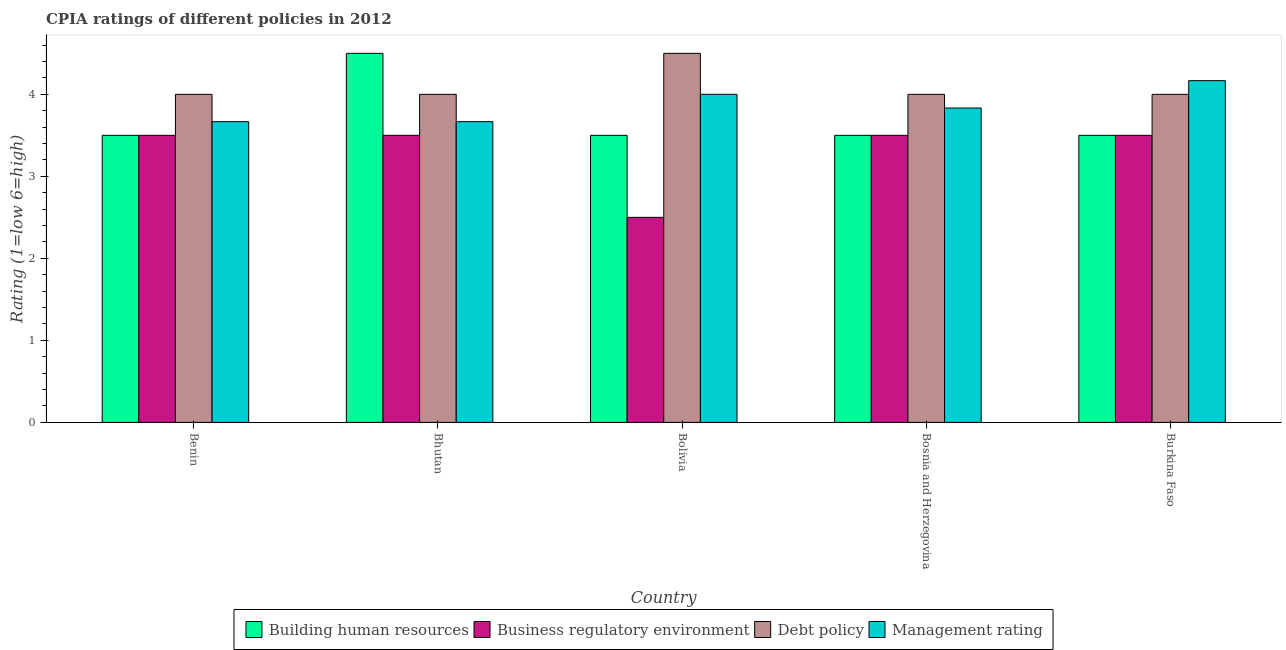How many groups of bars are there?
Offer a terse response. 5. How many bars are there on the 5th tick from the left?
Offer a very short reply. 4. How many bars are there on the 2nd tick from the right?
Your response must be concise. 4. What is the label of the 3rd group of bars from the left?
Make the answer very short. Bolivia. In how many cases, is the number of bars for a given country not equal to the number of legend labels?
Keep it short and to the point. 0. In which country was the cpia rating of building human resources maximum?
Make the answer very short. Bhutan. What is the difference between the cpia rating of debt policy in Burkina Faso and the cpia rating of management in Benin?
Give a very brief answer. 0.33. What is the average cpia rating of business regulatory environment per country?
Your answer should be compact. 3.3. What is the difference between the cpia rating of management and cpia rating of building human resources in Bolivia?
Ensure brevity in your answer.  0.5. In how many countries, is the cpia rating of building human resources greater than 2.4 ?
Offer a terse response. 5. What is the difference between the highest and the second highest cpia rating of management?
Give a very brief answer. 0.17. What is the difference between the highest and the lowest cpia rating of building human resources?
Offer a terse response. 1. In how many countries, is the cpia rating of management greater than the average cpia rating of management taken over all countries?
Offer a terse response. 2. What does the 4th bar from the left in Bhutan represents?
Make the answer very short. Management rating. What does the 2nd bar from the right in Bhutan represents?
Keep it short and to the point. Debt policy. Is it the case that in every country, the sum of the cpia rating of building human resources and cpia rating of business regulatory environment is greater than the cpia rating of debt policy?
Provide a succinct answer. Yes. How many bars are there?
Keep it short and to the point. 20. Are all the bars in the graph horizontal?
Your answer should be very brief. No. How many countries are there in the graph?
Provide a succinct answer. 5. What is the difference between two consecutive major ticks on the Y-axis?
Keep it short and to the point. 1. Does the graph contain grids?
Offer a terse response. No. How are the legend labels stacked?
Make the answer very short. Horizontal. What is the title of the graph?
Keep it short and to the point. CPIA ratings of different policies in 2012. What is the label or title of the X-axis?
Provide a short and direct response. Country. What is the Rating (1=low 6=high) of Business regulatory environment in Benin?
Your response must be concise. 3.5. What is the Rating (1=low 6=high) in Debt policy in Benin?
Offer a terse response. 4. What is the Rating (1=low 6=high) of Management rating in Benin?
Offer a very short reply. 3.67. What is the Rating (1=low 6=high) of Debt policy in Bhutan?
Give a very brief answer. 4. What is the Rating (1=low 6=high) of Management rating in Bhutan?
Keep it short and to the point. 3.67. What is the Rating (1=low 6=high) of Debt policy in Bolivia?
Offer a terse response. 4.5. What is the Rating (1=low 6=high) in Management rating in Bolivia?
Ensure brevity in your answer.  4. What is the Rating (1=low 6=high) in Building human resources in Bosnia and Herzegovina?
Your response must be concise. 3.5. What is the Rating (1=low 6=high) of Management rating in Bosnia and Herzegovina?
Offer a terse response. 3.83. What is the Rating (1=low 6=high) in Building human resources in Burkina Faso?
Your answer should be very brief. 3.5. What is the Rating (1=low 6=high) of Management rating in Burkina Faso?
Make the answer very short. 4.17. Across all countries, what is the maximum Rating (1=low 6=high) of Building human resources?
Keep it short and to the point. 4.5. Across all countries, what is the maximum Rating (1=low 6=high) of Business regulatory environment?
Provide a succinct answer. 3.5. Across all countries, what is the maximum Rating (1=low 6=high) of Debt policy?
Offer a very short reply. 4.5. Across all countries, what is the maximum Rating (1=low 6=high) in Management rating?
Your answer should be very brief. 4.17. Across all countries, what is the minimum Rating (1=low 6=high) in Building human resources?
Your answer should be very brief. 3.5. Across all countries, what is the minimum Rating (1=low 6=high) in Management rating?
Give a very brief answer. 3.67. What is the total Rating (1=low 6=high) in Building human resources in the graph?
Your answer should be compact. 18.5. What is the total Rating (1=low 6=high) of Debt policy in the graph?
Make the answer very short. 20.5. What is the total Rating (1=low 6=high) of Management rating in the graph?
Your response must be concise. 19.33. What is the difference between the Rating (1=low 6=high) in Building human resources in Benin and that in Bhutan?
Offer a very short reply. -1. What is the difference between the Rating (1=low 6=high) of Business regulatory environment in Benin and that in Bhutan?
Offer a terse response. 0. What is the difference between the Rating (1=low 6=high) in Debt policy in Benin and that in Bhutan?
Offer a terse response. 0. What is the difference between the Rating (1=low 6=high) in Management rating in Benin and that in Bhutan?
Your answer should be compact. 0. What is the difference between the Rating (1=low 6=high) of Building human resources in Benin and that in Bolivia?
Ensure brevity in your answer.  0. What is the difference between the Rating (1=low 6=high) in Business regulatory environment in Benin and that in Bolivia?
Your answer should be compact. 1. What is the difference between the Rating (1=low 6=high) in Debt policy in Benin and that in Bolivia?
Ensure brevity in your answer.  -0.5. What is the difference between the Rating (1=low 6=high) in Management rating in Benin and that in Bolivia?
Your answer should be compact. -0.33. What is the difference between the Rating (1=low 6=high) in Building human resources in Benin and that in Bosnia and Herzegovina?
Your response must be concise. 0. What is the difference between the Rating (1=low 6=high) in Business regulatory environment in Benin and that in Bosnia and Herzegovina?
Give a very brief answer. 0. What is the difference between the Rating (1=low 6=high) of Debt policy in Benin and that in Bosnia and Herzegovina?
Offer a terse response. 0. What is the difference between the Rating (1=low 6=high) in Business regulatory environment in Benin and that in Burkina Faso?
Keep it short and to the point. 0. What is the difference between the Rating (1=low 6=high) in Debt policy in Benin and that in Burkina Faso?
Your answer should be very brief. 0. What is the difference between the Rating (1=low 6=high) of Management rating in Benin and that in Burkina Faso?
Your answer should be very brief. -0.5. What is the difference between the Rating (1=low 6=high) in Debt policy in Bhutan and that in Bolivia?
Your answer should be compact. -0.5. What is the difference between the Rating (1=low 6=high) in Building human resources in Bhutan and that in Bosnia and Herzegovina?
Give a very brief answer. 1. What is the difference between the Rating (1=low 6=high) in Business regulatory environment in Bhutan and that in Bosnia and Herzegovina?
Your answer should be very brief. 0. What is the difference between the Rating (1=low 6=high) of Building human resources in Bhutan and that in Burkina Faso?
Provide a succinct answer. 1. What is the difference between the Rating (1=low 6=high) of Business regulatory environment in Bhutan and that in Burkina Faso?
Provide a short and direct response. 0. What is the difference between the Rating (1=low 6=high) in Management rating in Bhutan and that in Burkina Faso?
Your answer should be compact. -0.5. What is the difference between the Rating (1=low 6=high) in Building human resources in Bolivia and that in Bosnia and Herzegovina?
Ensure brevity in your answer.  0. What is the difference between the Rating (1=low 6=high) in Business regulatory environment in Bolivia and that in Bosnia and Herzegovina?
Provide a succinct answer. -1. What is the difference between the Rating (1=low 6=high) of Management rating in Bolivia and that in Bosnia and Herzegovina?
Your answer should be compact. 0.17. What is the difference between the Rating (1=low 6=high) of Business regulatory environment in Bolivia and that in Burkina Faso?
Your answer should be very brief. -1. What is the difference between the Rating (1=low 6=high) of Business regulatory environment in Bosnia and Herzegovina and that in Burkina Faso?
Make the answer very short. 0. What is the difference between the Rating (1=low 6=high) in Building human resources in Benin and the Rating (1=low 6=high) in Business regulatory environment in Bhutan?
Ensure brevity in your answer.  0. What is the difference between the Rating (1=low 6=high) of Business regulatory environment in Benin and the Rating (1=low 6=high) of Management rating in Bhutan?
Offer a very short reply. -0.17. What is the difference between the Rating (1=low 6=high) in Debt policy in Benin and the Rating (1=low 6=high) in Management rating in Bhutan?
Offer a very short reply. 0.33. What is the difference between the Rating (1=low 6=high) of Building human resources in Benin and the Rating (1=low 6=high) of Business regulatory environment in Bolivia?
Offer a very short reply. 1. What is the difference between the Rating (1=low 6=high) of Building human resources in Benin and the Rating (1=low 6=high) of Debt policy in Bolivia?
Your response must be concise. -1. What is the difference between the Rating (1=low 6=high) of Business regulatory environment in Benin and the Rating (1=low 6=high) of Debt policy in Bolivia?
Offer a terse response. -1. What is the difference between the Rating (1=low 6=high) in Business regulatory environment in Benin and the Rating (1=low 6=high) in Management rating in Bolivia?
Your answer should be compact. -0.5. What is the difference between the Rating (1=low 6=high) in Debt policy in Benin and the Rating (1=low 6=high) in Management rating in Bolivia?
Your answer should be very brief. 0. What is the difference between the Rating (1=low 6=high) of Building human resources in Benin and the Rating (1=low 6=high) of Management rating in Bosnia and Herzegovina?
Offer a very short reply. -0.33. What is the difference between the Rating (1=low 6=high) in Business regulatory environment in Benin and the Rating (1=low 6=high) in Management rating in Bosnia and Herzegovina?
Give a very brief answer. -0.33. What is the difference between the Rating (1=low 6=high) of Debt policy in Benin and the Rating (1=low 6=high) of Management rating in Bosnia and Herzegovina?
Give a very brief answer. 0.17. What is the difference between the Rating (1=low 6=high) of Building human resources in Benin and the Rating (1=low 6=high) of Debt policy in Burkina Faso?
Your response must be concise. -0.5. What is the difference between the Rating (1=low 6=high) of Business regulatory environment in Benin and the Rating (1=low 6=high) of Debt policy in Burkina Faso?
Keep it short and to the point. -0.5. What is the difference between the Rating (1=low 6=high) of Business regulatory environment in Benin and the Rating (1=low 6=high) of Management rating in Burkina Faso?
Offer a terse response. -0.67. What is the difference between the Rating (1=low 6=high) in Building human resources in Bhutan and the Rating (1=low 6=high) in Business regulatory environment in Bolivia?
Provide a short and direct response. 2. What is the difference between the Rating (1=low 6=high) in Building human resources in Bhutan and the Rating (1=low 6=high) in Debt policy in Bolivia?
Offer a terse response. 0. What is the difference between the Rating (1=low 6=high) of Business regulatory environment in Bhutan and the Rating (1=low 6=high) of Management rating in Bolivia?
Your answer should be very brief. -0.5. What is the difference between the Rating (1=low 6=high) in Debt policy in Bhutan and the Rating (1=low 6=high) in Management rating in Bolivia?
Give a very brief answer. 0. What is the difference between the Rating (1=low 6=high) in Building human resources in Bhutan and the Rating (1=low 6=high) in Debt policy in Bosnia and Herzegovina?
Ensure brevity in your answer.  0.5. What is the difference between the Rating (1=low 6=high) of Business regulatory environment in Bhutan and the Rating (1=low 6=high) of Management rating in Bosnia and Herzegovina?
Make the answer very short. -0.33. What is the difference between the Rating (1=low 6=high) in Debt policy in Bhutan and the Rating (1=low 6=high) in Management rating in Bosnia and Herzegovina?
Your answer should be compact. 0.17. What is the difference between the Rating (1=low 6=high) of Building human resources in Bhutan and the Rating (1=low 6=high) of Debt policy in Burkina Faso?
Offer a terse response. 0.5. What is the difference between the Rating (1=low 6=high) of Building human resources in Bhutan and the Rating (1=low 6=high) of Management rating in Burkina Faso?
Offer a terse response. 0.33. What is the difference between the Rating (1=low 6=high) of Business regulatory environment in Bhutan and the Rating (1=low 6=high) of Management rating in Burkina Faso?
Make the answer very short. -0.67. What is the difference between the Rating (1=low 6=high) of Building human resources in Bolivia and the Rating (1=low 6=high) of Business regulatory environment in Bosnia and Herzegovina?
Your response must be concise. 0. What is the difference between the Rating (1=low 6=high) of Business regulatory environment in Bolivia and the Rating (1=low 6=high) of Debt policy in Bosnia and Herzegovina?
Offer a very short reply. -1.5. What is the difference between the Rating (1=low 6=high) in Business regulatory environment in Bolivia and the Rating (1=low 6=high) in Management rating in Bosnia and Herzegovina?
Keep it short and to the point. -1.33. What is the difference between the Rating (1=low 6=high) of Debt policy in Bolivia and the Rating (1=low 6=high) of Management rating in Bosnia and Herzegovina?
Ensure brevity in your answer.  0.67. What is the difference between the Rating (1=low 6=high) in Business regulatory environment in Bolivia and the Rating (1=low 6=high) in Management rating in Burkina Faso?
Your answer should be very brief. -1.67. What is the difference between the Rating (1=low 6=high) in Debt policy in Bolivia and the Rating (1=low 6=high) in Management rating in Burkina Faso?
Provide a succinct answer. 0.33. What is the difference between the Rating (1=low 6=high) in Building human resources in Bosnia and Herzegovina and the Rating (1=low 6=high) in Business regulatory environment in Burkina Faso?
Your answer should be compact. 0. What is the average Rating (1=low 6=high) of Building human resources per country?
Offer a terse response. 3.7. What is the average Rating (1=low 6=high) of Business regulatory environment per country?
Your answer should be very brief. 3.3. What is the average Rating (1=low 6=high) in Management rating per country?
Your response must be concise. 3.87. What is the difference between the Rating (1=low 6=high) of Building human resources and Rating (1=low 6=high) of Business regulatory environment in Benin?
Provide a short and direct response. 0. What is the difference between the Rating (1=low 6=high) of Business regulatory environment and Rating (1=low 6=high) of Debt policy in Bhutan?
Keep it short and to the point. -0.5. What is the difference between the Rating (1=low 6=high) of Building human resources and Rating (1=low 6=high) of Debt policy in Bolivia?
Give a very brief answer. -1. What is the difference between the Rating (1=low 6=high) of Business regulatory environment and Rating (1=low 6=high) of Debt policy in Bolivia?
Keep it short and to the point. -2. What is the difference between the Rating (1=low 6=high) in Debt policy and Rating (1=low 6=high) in Management rating in Bolivia?
Your answer should be compact. 0.5. What is the difference between the Rating (1=low 6=high) in Building human resources and Rating (1=low 6=high) in Business regulatory environment in Bosnia and Herzegovina?
Ensure brevity in your answer.  0. What is the difference between the Rating (1=low 6=high) in Business regulatory environment and Rating (1=low 6=high) in Management rating in Bosnia and Herzegovina?
Your answer should be compact. -0.33. What is the difference between the Rating (1=low 6=high) of Building human resources and Rating (1=low 6=high) of Business regulatory environment in Burkina Faso?
Make the answer very short. 0. What is the difference between the Rating (1=low 6=high) of Building human resources and Rating (1=low 6=high) of Management rating in Burkina Faso?
Keep it short and to the point. -0.67. What is the difference between the Rating (1=low 6=high) of Business regulatory environment and Rating (1=low 6=high) of Debt policy in Burkina Faso?
Give a very brief answer. -0.5. What is the difference between the Rating (1=low 6=high) of Business regulatory environment and Rating (1=low 6=high) of Management rating in Burkina Faso?
Offer a terse response. -0.67. What is the difference between the Rating (1=low 6=high) in Debt policy and Rating (1=low 6=high) in Management rating in Burkina Faso?
Provide a short and direct response. -0.17. What is the ratio of the Rating (1=low 6=high) in Building human resources in Benin to that in Bhutan?
Provide a succinct answer. 0.78. What is the ratio of the Rating (1=low 6=high) in Debt policy in Benin to that in Bhutan?
Ensure brevity in your answer.  1. What is the ratio of the Rating (1=low 6=high) of Management rating in Benin to that in Bhutan?
Ensure brevity in your answer.  1. What is the ratio of the Rating (1=low 6=high) in Building human resources in Benin to that in Bolivia?
Keep it short and to the point. 1. What is the ratio of the Rating (1=low 6=high) of Building human resources in Benin to that in Bosnia and Herzegovina?
Ensure brevity in your answer.  1. What is the ratio of the Rating (1=low 6=high) in Debt policy in Benin to that in Bosnia and Herzegovina?
Your answer should be compact. 1. What is the ratio of the Rating (1=low 6=high) in Management rating in Benin to that in Bosnia and Herzegovina?
Offer a very short reply. 0.96. What is the ratio of the Rating (1=low 6=high) in Business regulatory environment in Benin to that in Burkina Faso?
Ensure brevity in your answer.  1. What is the ratio of the Rating (1=low 6=high) of Debt policy in Benin to that in Burkina Faso?
Provide a succinct answer. 1. What is the ratio of the Rating (1=low 6=high) of Debt policy in Bhutan to that in Bolivia?
Offer a terse response. 0.89. What is the ratio of the Rating (1=low 6=high) of Management rating in Bhutan to that in Bolivia?
Your response must be concise. 0.92. What is the ratio of the Rating (1=low 6=high) in Debt policy in Bhutan to that in Bosnia and Herzegovina?
Make the answer very short. 1. What is the ratio of the Rating (1=low 6=high) of Management rating in Bhutan to that in Bosnia and Herzegovina?
Make the answer very short. 0.96. What is the ratio of the Rating (1=low 6=high) of Management rating in Bhutan to that in Burkina Faso?
Your response must be concise. 0.88. What is the ratio of the Rating (1=low 6=high) of Management rating in Bolivia to that in Bosnia and Herzegovina?
Keep it short and to the point. 1.04. What is the ratio of the Rating (1=low 6=high) of Debt policy in Bolivia to that in Burkina Faso?
Ensure brevity in your answer.  1.12. What is the ratio of the Rating (1=low 6=high) in Management rating in Bolivia to that in Burkina Faso?
Your answer should be very brief. 0.96. What is the ratio of the Rating (1=low 6=high) of Debt policy in Bosnia and Herzegovina to that in Burkina Faso?
Your answer should be very brief. 1. What is the ratio of the Rating (1=low 6=high) of Management rating in Bosnia and Herzegovina to that in Burkina Faso?
Ensure brevity in your answer.  0.92. What is the difference between the highest and the second highest Rating (1=low 6=high) in Building human resources?
Make the answer very short. 1. What is the difference between the highest and the second highest Rating (1=low 6=high) of Debt policy?
Your response must be concise. 0.5. What is the difference between the highest and the second highest Rating (1=low 6=high) of Management rating?
Your response must be concise. 0.17. What is the difference between the highest and the lowest Rating (1=low 6=high) in Business regulatory environment?
Offer a terse response. 1. What is the difference between the highest and the lowest Rating (1=low 6=high) of Debt policy?
Keep it short and to the point. 0.5. 